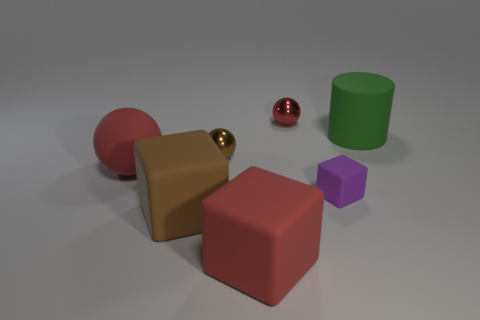The big rubber thing that is the same color as the matte sphere is what shape?
Keep it short and to the point. Cube. Is there anything else that has the same shape as the tiny purple thing?
Make the answer very short. Yes. How many other things are the same size as the purple matte block?
Make the answer very short. 2. Does the red ball that is on the right side of the brown matte cube have the same size as the brown object that is behind the small purple object?
Offer a very short reply. Yes. How many objects are either blue spheres or matte cubes that are in front of the brown matte block?
Make the answer very short. 1. There is a metallic ball that is in front of the big green cylinder; what size is it?
Ensure brevity in your answer.  Small. Are there fewer big blocks behind the large rubber sphere than large brown blocks on the right side of the small brown shiny ball?
Your response must be concise. No. The large object that is left of the tiny red metal thing and behind the big brown object is made of what material?
Make the answer very short. Rubber. What is the shape of the brown object in front of the purple rubber object that is behind the big brown object?
Provide a succinct answer. Cube. Do the big matte cylinder and the matte ball have the same color?
Ensure brevity in your answer.  No. 